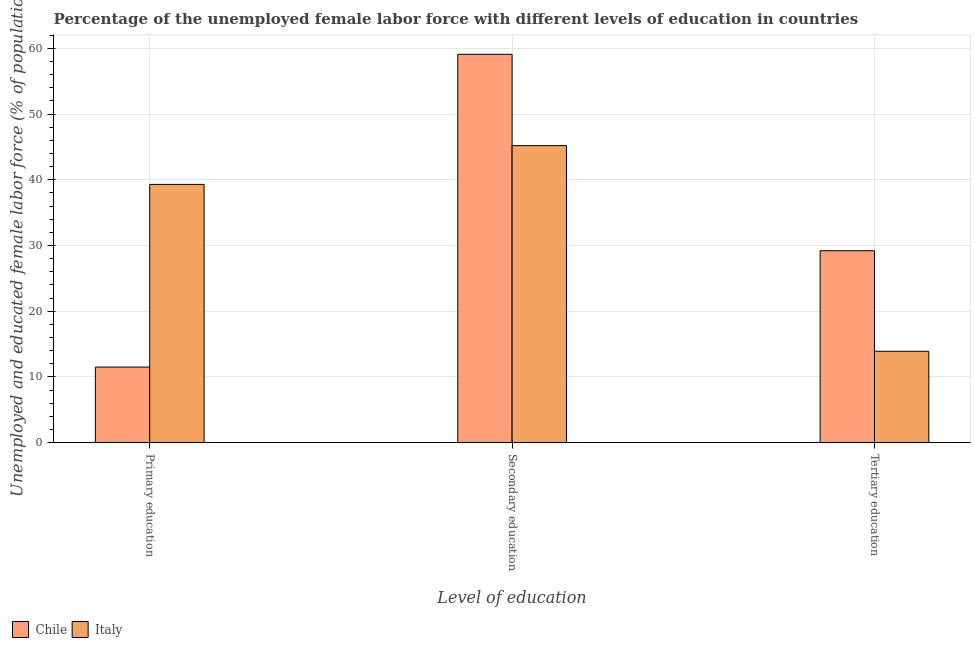How many groups of bars are there?
Provide a succinct answer. 3. How many bars are there on the 1st tick from the left?
Your answer should be compact. 2. How many bars are there on the 1st tick from the right?
Give a very brief answer. 2. What is the percentage of female labor force who received secondary education in Italy?
Your answer should be compact. 45.2. Across all countries, what is the maximum percentage of female labor force who received primary education?
Offer a terse response. 39.3. Across all countries, what is the minimum percentage of female labor force who received secondary education?
Provide a succinct answer. 45.2. In which country was the percentage of female labor force who received secondary education maximum?
Ensure brevity in your answer.  Chile. In which country was the percentage of female labor force who received tertiary education minimum?
Your answer should be very brief. Italy. What is the total percentage of female labor force who received primary education in the graph?
Offer a terse response. 50.8. What is the difference between the percentage of female labor force who received tertiary education in Chile and that in Italy?
Make the answer very short. 15.3. What is the difference between the percentage of female labor force who received secondary education in Chile and the percentage of female labor force who received tertiary education in Italy?
Your answer should be compact. 45.2. What is the average percentage of female labor force who received secondary education per country?
Your answer should be very brief. 52.15. What is the difference between the percentage of female labor force who received secondary education and percentage of female labor force who received primary education in Chile?
Keep it short and to the point. 47.6. In how many countries, is the percentage of female labor force who received primary education greater than 20 %?
Provide a succinct answer. 1. What is the ratio of the percentage of female labor force who received tertiary education in Chile to that in Italy?
Offer a very short reply. 2.1. Is the difference between the percentage of female labor force who received primary education in Chile and Italy greater than the difference between the percentage of female labor force who received secondary education in Chile and Italy?
Offer a very short reply. No. What is the difference between the highest and the second highest percentage of female labor force who received primary education?
Provide a short and direct response. 27.8. What is the difference between the highest and the lowest percentage of female labor force who received secondary education?
Your answer should be very brief. 13.9. What does the 2nd bar from the right in Primary education represents?
Keep it short and to the point. Chile. Is it the case that in every country, the sum of the percentage of female labor force who received primary education and percentage of female labor force who received secondary education is greater than the percentage of female labor force who received tertiary education?
Your answer should be very brief. Yes. Are all the bars in the graph horizontal?
Offer a very short reply. No. Where does the legend appear in the graph?
Give a very brief answer. Bottom left. How many legend labels are there?
Provide a succinct answer. 2. What is the title of the graph?
Offer a very short reply. Percentage of the unemployed female labor force with different levels of education in countries. What is the label or title of the X-axis?
Give a very brief answer. Level of education. What is the label or title of the Y-axis?
Make the answer very short. Unemployed and educated female labor force (% of population). What is the Unemployed and educated female labor force (% of population) of Italy in Primary education?
Make the answer very short. 39.3. What is the Unemployed and educated female labor force (% of population) in Chile in Secondary education?
Offer a terse response. 59.1. What is the Unemployed and educated female labor force (% of population) in Italy in Secondary education?
Provide a short and direct response. 45.2. What is the Unemployed and educated female labor force (% of population) in Chile in Tertiary education?
Provide a succinct answer. 29.2. What is the Unemployed and educated female labor force (% of population) in Italy in Tertiary education?
Your response must be concise. 13.9. Across all Level of education, what is the maximum Unemployed and educated female labor force (% of population) of Chile?
Offer a very short reply. 59.1. Across all Level of education, what is the maximum Unemployed and educated female labor force (% of population) of Italy?
Give a very brief answer. 45.2. Across all Level of education, what is the minimum Unemployed and educated female labor force (% of population) of Chile?
Provide a short and direct response. 11.5. Across all Level of education, what is the minimum Unemployed and educated female labor force (% of population) of Italy?
Your answer should be compact. 13.9. What is the total Unemployed and educated female labor force (% of population) of Chile in the graph?
Your answer should be compact. 99.8. What is the total Unemployed and educated female labor force (% of population) of Italy in the graph?
Your answer should be compact. 98.4. What is the difference between the Unemployed and educated female labor force (% of population) of Chile in Primary education and that in Secondary education?
Make the answer very short. -47.6. What is the difference between the Unemployed and educated female labor force (% of population) of Chile in Primary education and that in Tertiary education?
Ensure brevity in your answer.  -17.7. What is the difference between the Unemployed and educated female labor force (% of population) in Italy in Primary education and that in Tertiary education?
Make the answer very short. 25.4. What is the difference between the Unemployed and educated female labor force (% of population) in Chile in Secondary education and that in Tertiary education?
Provide a succinct answer. 29.9. What is the difference between the Unemployed and educated female labor force (% of population) of Italy in Secondary education and that in Tertiary education?
Make the answer very short. 31.3. What is the difference between the Unemployed and educated female labor force (% of population) in Chile in Primary education and the Unemployed and educated female labor force (% of population) in Italy in Secondary education?
Give a very brief answer. -33.7. What is the difference between the Unemployed and educated female labor force (% of population) in Chile in Primary education and the Unemployed and educated female labor force (% of population) in Italy in Tertiary education?
Ensure brevity in your answer.  -2.4. What is the difference between the Unemployed and educated female labor force (% of population) in Chile in Secondary education and the Unemployed and educated female labor force (% of population) in Italy in Tertiary education?
Your answer should be very brief. 45.2. What is the average Unemployed and educated female labor force (% of population) of Chile per Level of education?
Give a very brief answer. 33.27. What is the average Unemployed and educated female labor force (% of population) in Italy per Level of education?
Offer a terse response. 32.8. What is the difference between the Unemployed and educated female labor force (% of population) in Chile and Unemployed and educated female labor force (% of population) in Italy in Primary education?
Your answer should be very brief. -27.8. What is the difference between the Unemployed and educated female labor force (% of population) of Chile and Unemployed and educated female labor force (% of population) of Italy in Tertiary education?
Keep it short and to the point. 15.3. What is the ratio of the Unemployed and educated female labor force (% of population) in Chile in Primary education to that in Secondary education?
Your answer should be compact. 0.19. What is the ratio of the Unemployed and educated female labor force (% of population) of Italy in Primary education to that in Secondary education?
Give a very brief answer. 0.87. What is the ratio of the Unemployed and educated female labor force (% of population) of Chile in Primary education to that in Tertiary education?
Make the answer very short. 0.39. What is the ratio of the Unemployed and educated female labor force (% of population) in Italy in Primary education to that in Tertiary education?
Your answer should be very brief. 2.83. What is the ratio of the Unemployed and educated female labor force (% of population) in Chile in Secondary education to that in Tertiary education?
Your answer should be very brief. 2.02. What is the ratio of the Unemployed and educated female labor force (% of population) of Italy in Secondary education to that in Tertiary education?
Your answer should be very brief. 3.25. What is the difference between the highest and the second highest Unemployed and educated female labor force (% of population) of Chile?
Keep it short and to the point. 29.9. What is the difference between the highest and the lowest Unemployed and educated female labor force (% of population) of Chile?
Make the answer very short. 47.6. What is the difference between the highest and the lowest Unemployed and educated female labor force (% of population) of Italy?
Your answer should be compact. 31.3. 